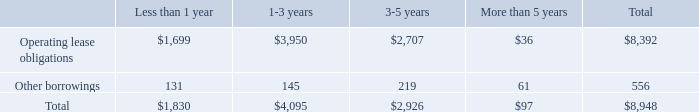Contractual Obligations
The following table summarizes our contractual obligations as of September 30, 2019 (in thousands):
Our principal executive offices, as well as our research and development facility, are located in approximately 29,000 square feet of office space in San Diego, California and the term of the lease continues through June 30, 2024. The average annual base rent under this lease is approximately $1.0 million per year. In connection with this lease, we received tenant improvement allowances totaling approximately $1.0 million. These lease incentives are being amortized as a reduction of rent expense over the term of the lease.
Our other offices are located in Paris, France; Amsterdam, The Netherlands; New York, New York; Barcelona, Spain; and London, United Kingdom. The
term of the Paris, France lease continues through July 31, 2021, with an annual base rent of approximately €0.4 million (or $0.4 million). The term of the
Amsterdam, The Netherlands lease continues through December 31, 2022, with an annual base rent of approximately €0.2 million (or $0.2 million). The term of
the New York, New York lease continues through November 30, 2024, with an annual base rent of approximately $0.2 million. The term of the Barcelona, Spain lease continues through May 31, 2023, with an annual base rent of approximately €0.1 million (or $0.1 million). The term of the London, United Kingdom lease continues through May 31, 2020, with an annual base rent of approximately £63,000 (or approximately $78,000). Our other offices are located in Paris, France; Amsterdam, The Netherlands; New York, New York; Barcelona, Spain; and London, United Kingdom. The term of the Paris, France lease continues through July 31, 2021, with an annual base rent of approximately €0.4 million (or $0.4 million). The term of the Amsterdam, The Netherlands lease continues through December 31, 2022, with an annual base rent of approximately €0.2 million (or $0.2 million). The term of the New York, New York lease continues through November 30, 2024, with an annual base rent of approximately $0.2 million. The term of the Barcelona, Spain lease continues through May 31, 2023, with an annual base rent of approximately €0.1 million (or $0.1 million). The term of the London, United Kingdom lease continues through May 31, 2020, with an annual base rent of approximately £63,000 (or approximately $78,000).
Other than the lease for our office space in San Diego, California, we do not believe that the leases for our offices are material to the Company. We believe our existing properties are in good condition and are sufficient and suitable for the conduct of its business.
Where are the principal executive offices, as well as research and development facility located? San diego, california. How much is the annual base rent for the office in Barcelona, Spain? Approximately €0.1 million (or $0.1 million). How much are the total overall contractual obligations ?
Answer scale should be: thousand. $8,948. What is the proportion of total operating lease obligations that expire in 3 years over total operating lease obligations? (1,699+3,950)/8,392 
Answer: 0.67. What is the ratio of contractual obligations that expire in less than 1 year to the ones that expire in 3-5 years? 1,830/2,926 
Answer: 0.63. What is the average contractual obligation based on the different term periods of the lease?
Answer scale should be: thousand. (1,830+4,095+2,926+97)/5 
Answer: 1789.6. 